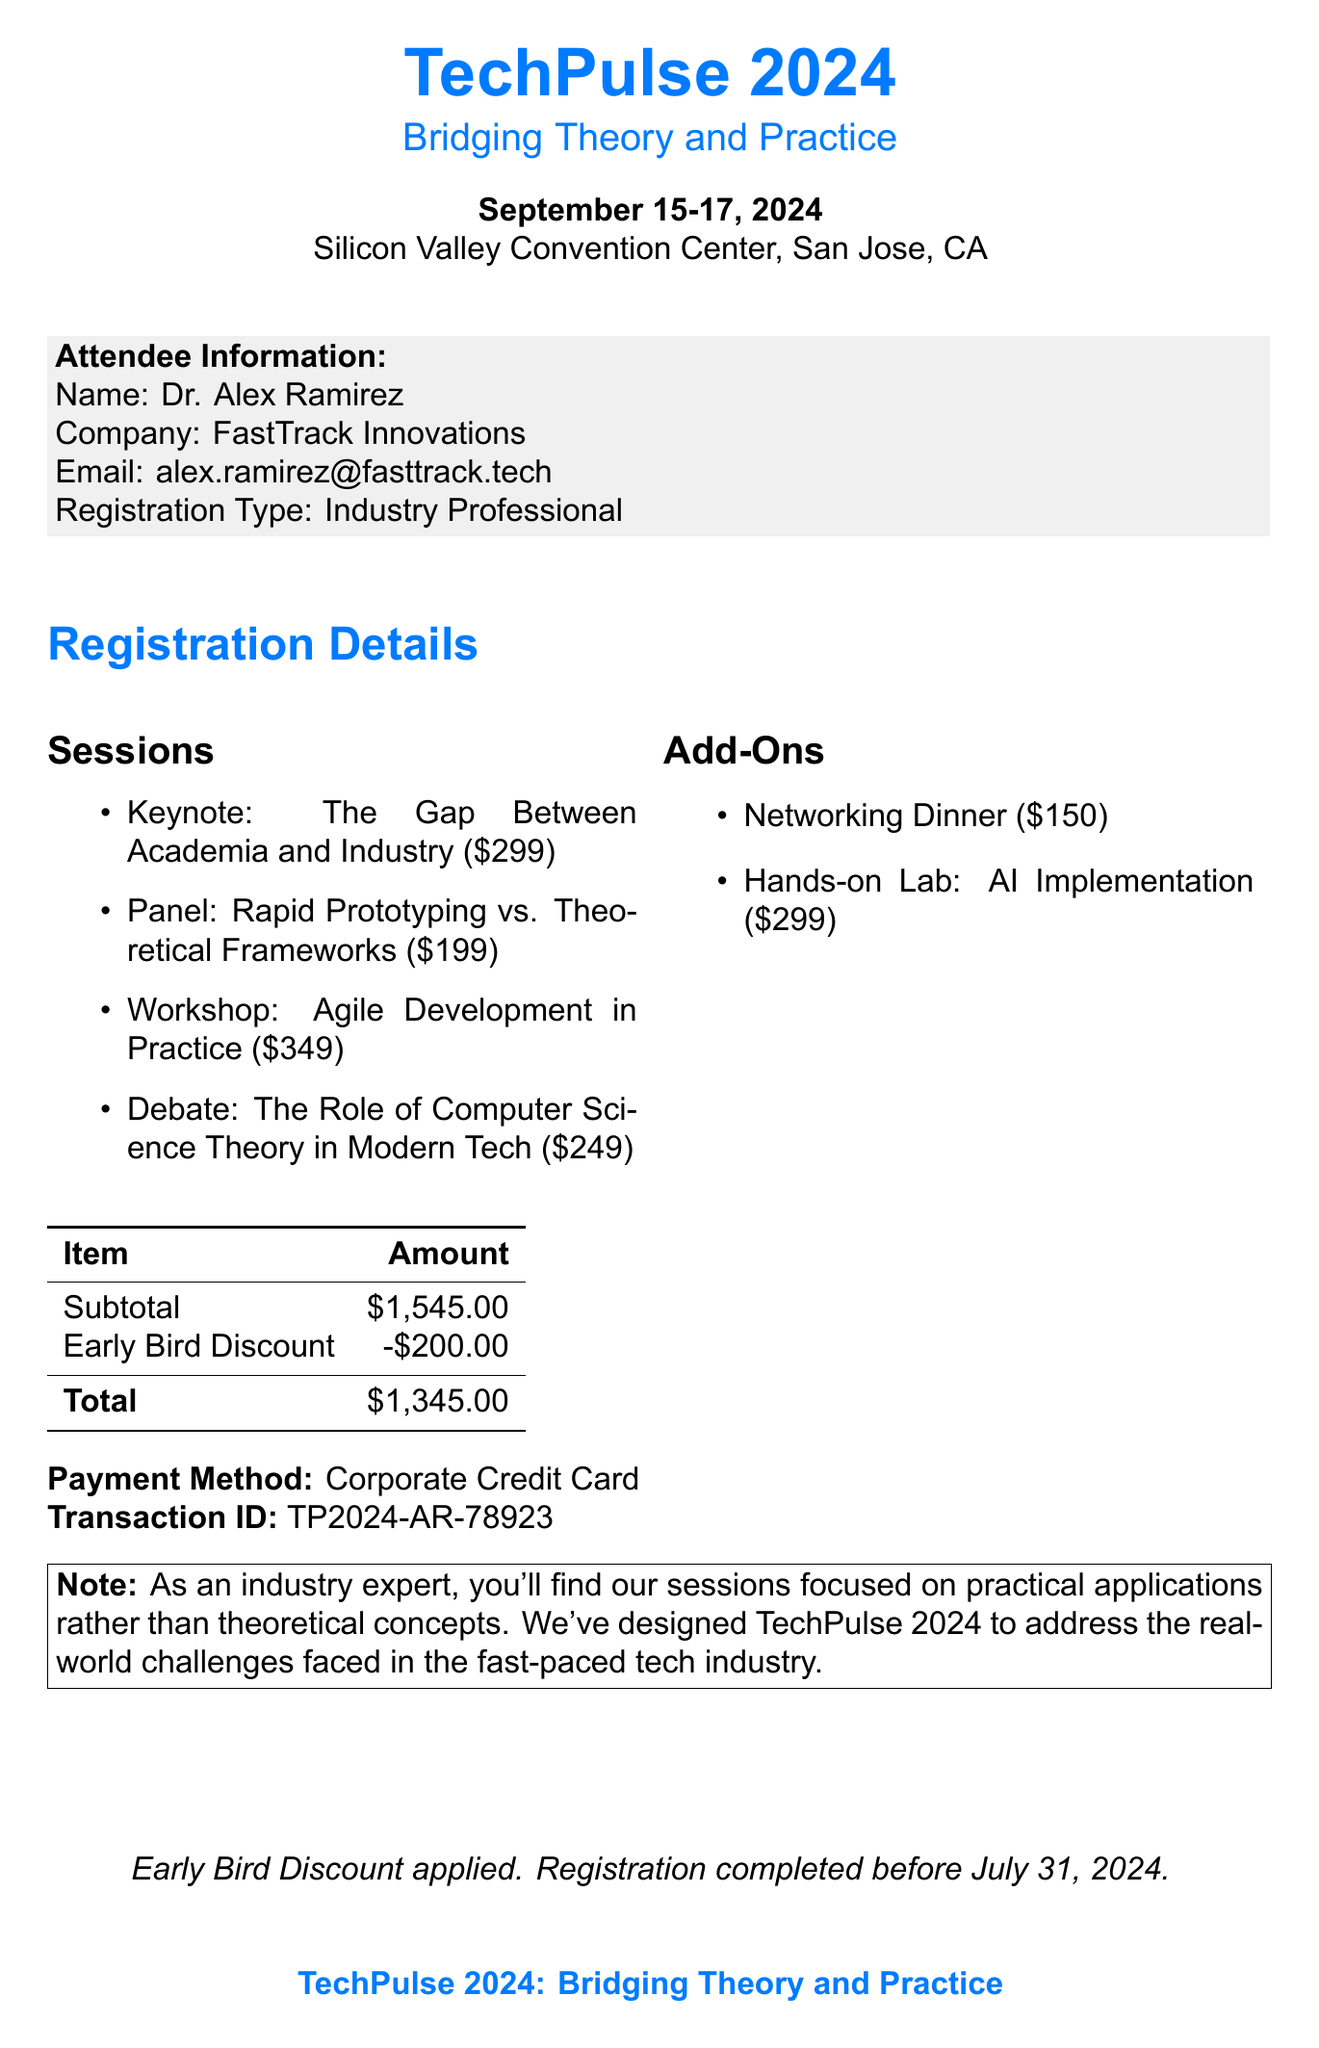What is the name of the conference? The document states the conference name at the beginning as "TechPulse 2024: Bridging Theory and Practice."
Answer: TechPulse 2024: Bridging Theory and Practice Who is the keynote speaker? The document lists Elon Musk as the keynote speaker for the session titled "The Gap Between Academia and Industry."
Answer: Elon Musk What is the total cost after the early bird discount? The total cost after applying the early bird discount is indicated as $1,345 in the financial summary.
Answer: $1,345 What is the early bird discount amount? The early bird discount amount is listed in the table as a deduction from the subtotal.
Answer: $200 What is the venue for the conference? The venue is specified in the document as the "Silicon Valley Convention Center, San Jose, CA."
Answer: Silicon Valley Convention Center, San Jose, CA How many sessions are listed in the document? The document details four sessions under the "Sessions" category.
Answer: Four What is the description of the add-on "Hands-on Lab: AI Implementation"? The document describes this add-on as focused on practical AI application techniques.
Answer: Practical AI application techniques What is the attendee's name? The attendee's name is mentioned in the attendee information section as "Dr. Alex Ramirez."
Answer: Dr. Alex Ramirez What is the payment method used for registration? The payment method is identified in the document as "Corporate Credit Card."
Answer: Corporate Credit Card 